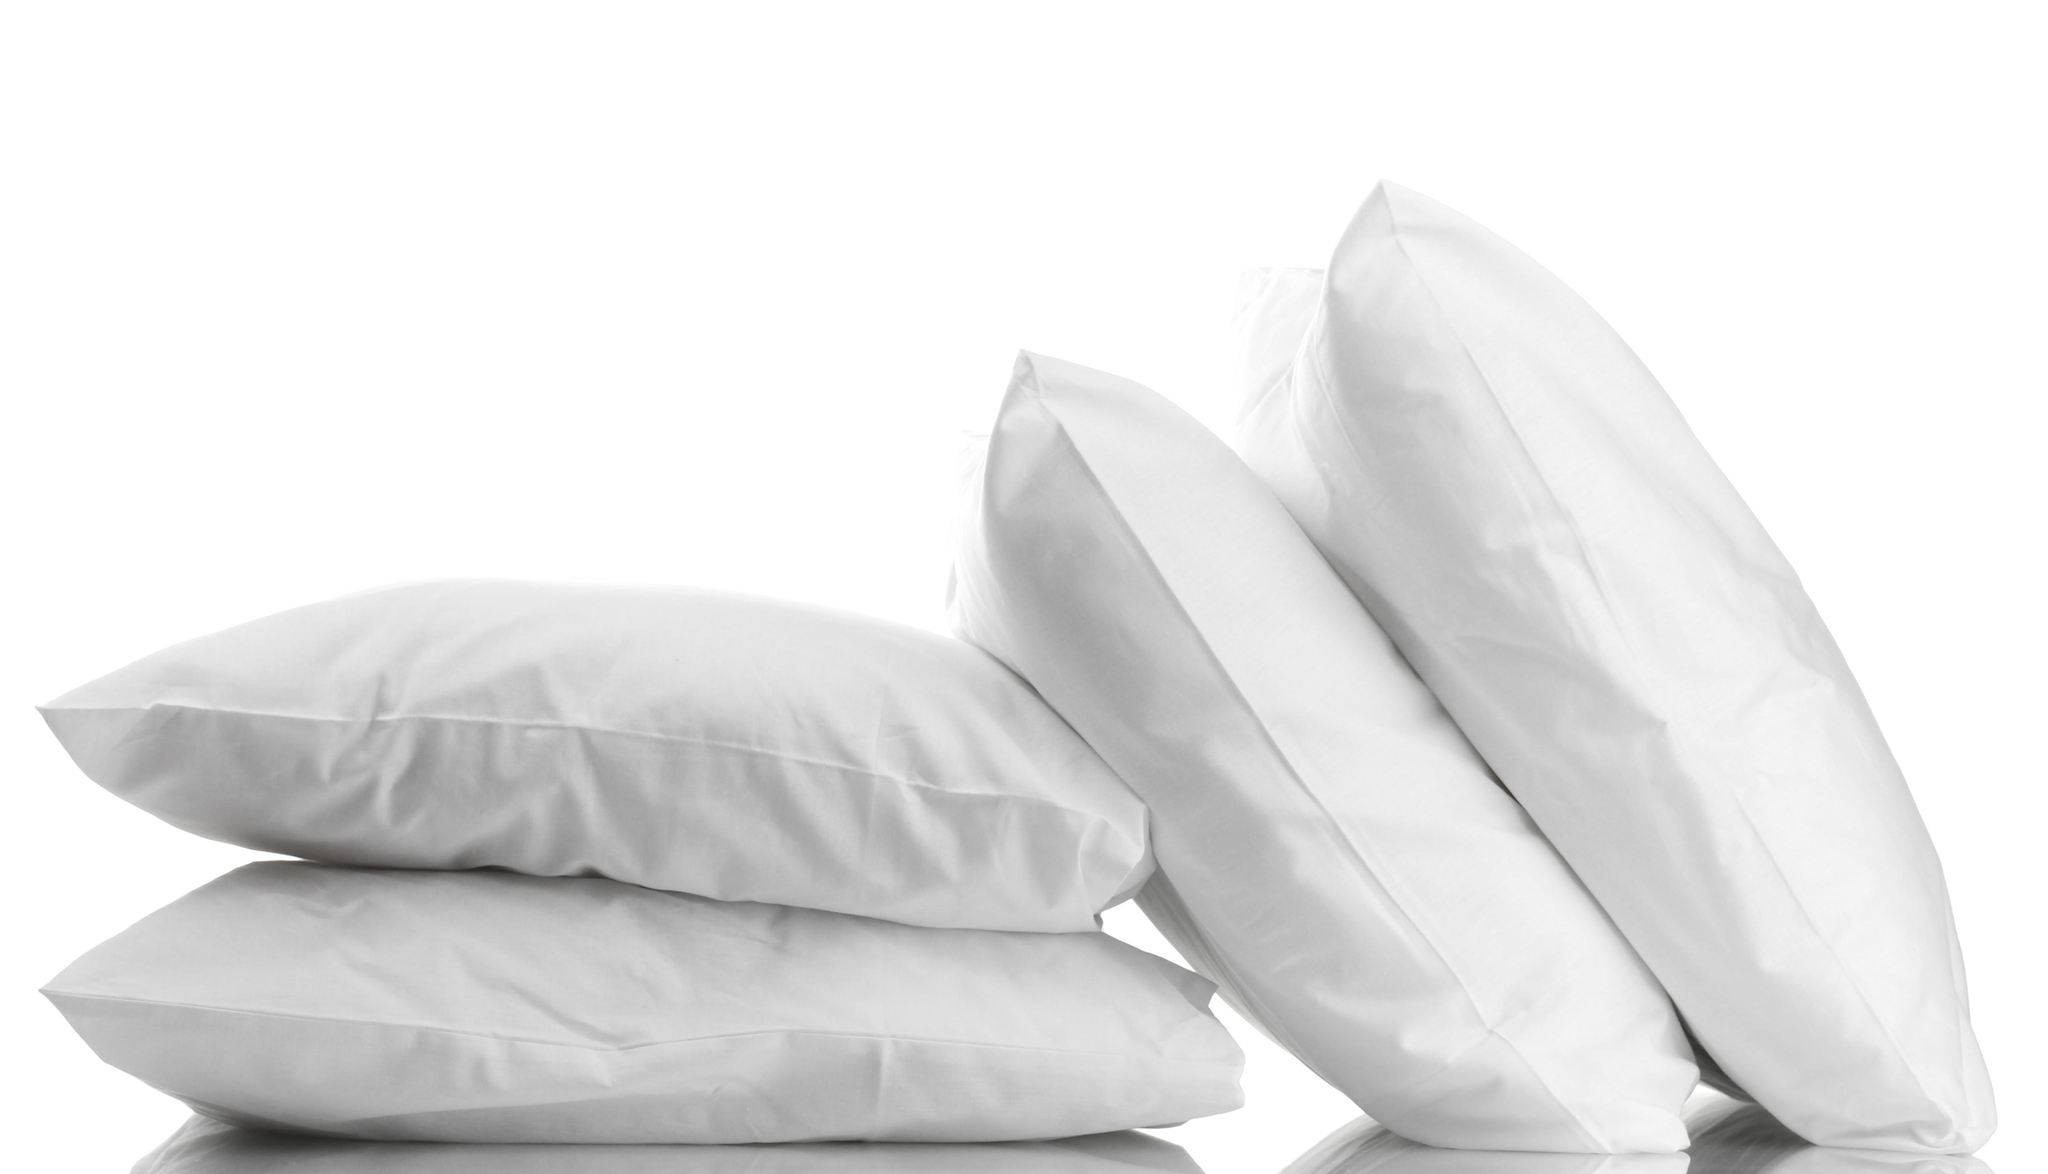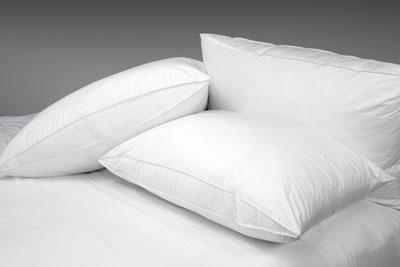The first image is the image on the left, the second image is the image on the right. Given the left and right images, does the statement "No less than four white pillows are stacked directly on top of one another" hold true? Answer yes or no. No. 